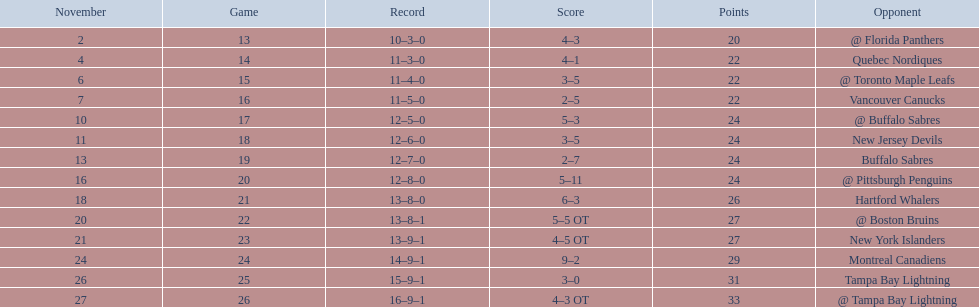What other team had the closest amount of wins? New York Islanders. Could you help me parse every detail presented in this table? {'header': ['November', 'Game', 'Record', 'Score', 'Points', 'Opponent'], 'rows': [['2', '13', '10–3–0', '4–3', '20', '@ Florida Panthers'], ['4', '14', '11–3–0', '4–1', '22', 'Quebec Nordiques'], ['6', '15', '11–4–0', '3–5', '22', '@ Toronto Maple Leafs'], ['7', '16', '11–5–0', '2–5', '22', 'Vancouver Canucks'], ['10', '17', '12–5–0', '5–3', '24', '@ Buffalo Sabres'], ['11', '18', '12–6–0', '3–5', '24', 'New Jersey Devils'], ['13', '19', '12–7–0', '2–7', '24', 'Buffalo Sabres'], ['16', '20', '12–8–0', '5–11', '24', '@ Pittsburgh Penguins'], ['18', '21', '13–8–0', '6–3', '26', 'Hartford Whalers'], ['20', '22', '13–8–1', '5–5 OT', '27', '@ Boston Bruins'], ['21', '23', '13–9–1', '4–5 OT', '27', 'New York Islanders'], ['24', '24', '14–9–1', '9–2', '29', 'Montreal Canadiens'], ['26', '25', '15–9–1', '3–0', '31', 'Tampa Bay Lightning'], ['27', '26', '16–9–1', '4–3 OT', '33', '@ Tampa Bay Lightning']]} 